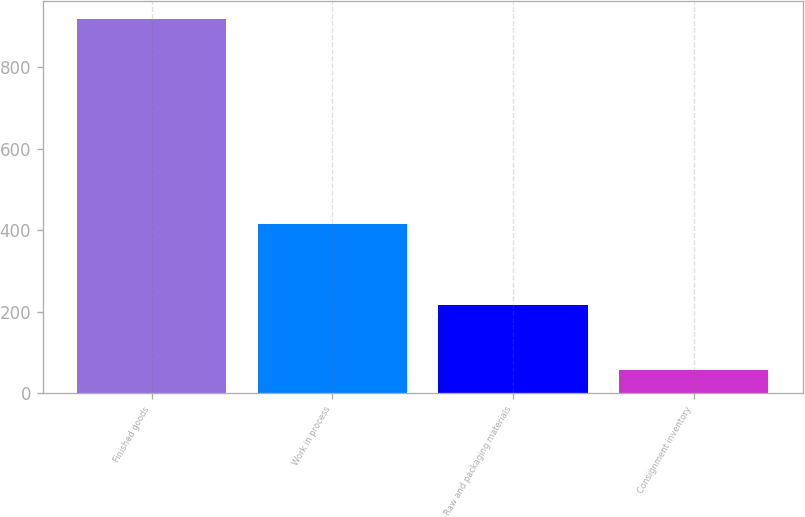<chart> <loc_0><loc_0><loc_500><loc_500><bar_chart><fcel>Finished goods<fcel>Work in process<fcel>Raw and packaging materials<fcel>Consignment inventory<nl><fcel>918<fcel>416<fcel>216<fcel>58<nl></chart> 